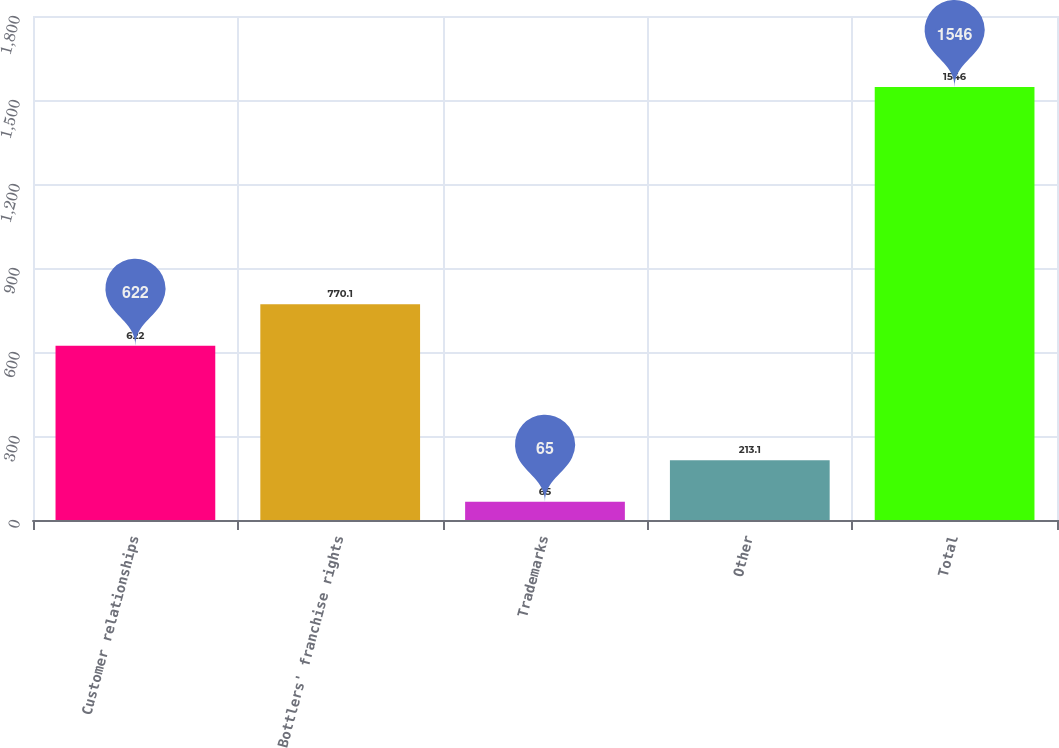<chart> <loc_0><loc_0><loc_500><loc_500><bar_chart><fcel>Customer relationships<fcel>Bottlers' franchise rights<fcel>Trademarks<fcel>Other<fcel>Total<nl><fcel>622<fcel>770.1<fcel>65<fcel>213.1<fcel>1546<nl></chart> 